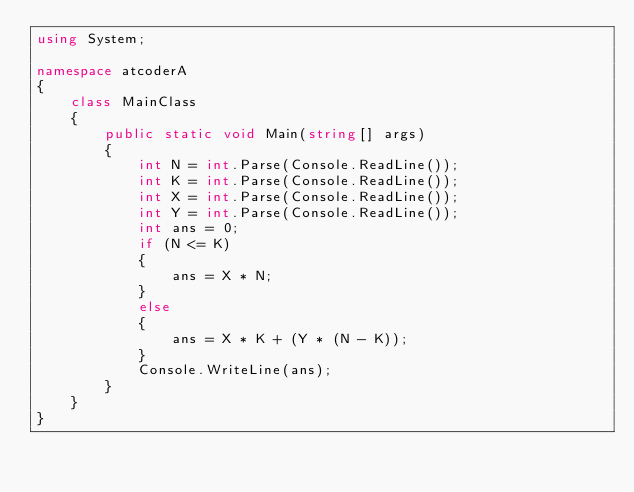<code> <loc_0><loc_0><loc_500><loc_500><_C#_>using System;

namespace atcoderA
{
    class MainClass
    {
        public static void Main(string[] args)
        {
            int N = int.Parse(Console.ReadLine());
            int K = int.Parse(Console.ReadLine());
            int X = int.Parse(Console.ReadLine());
            int Y = int.Parse(Console.ReadLine());
            int ans = 0;
            if (N <= K)
            {
                ans = X * N;
            }
            else
            {
                ans = X * K + (Y * (N - K));
            }
            Console.WriteLine(ans);
        }
    }
}</code> 